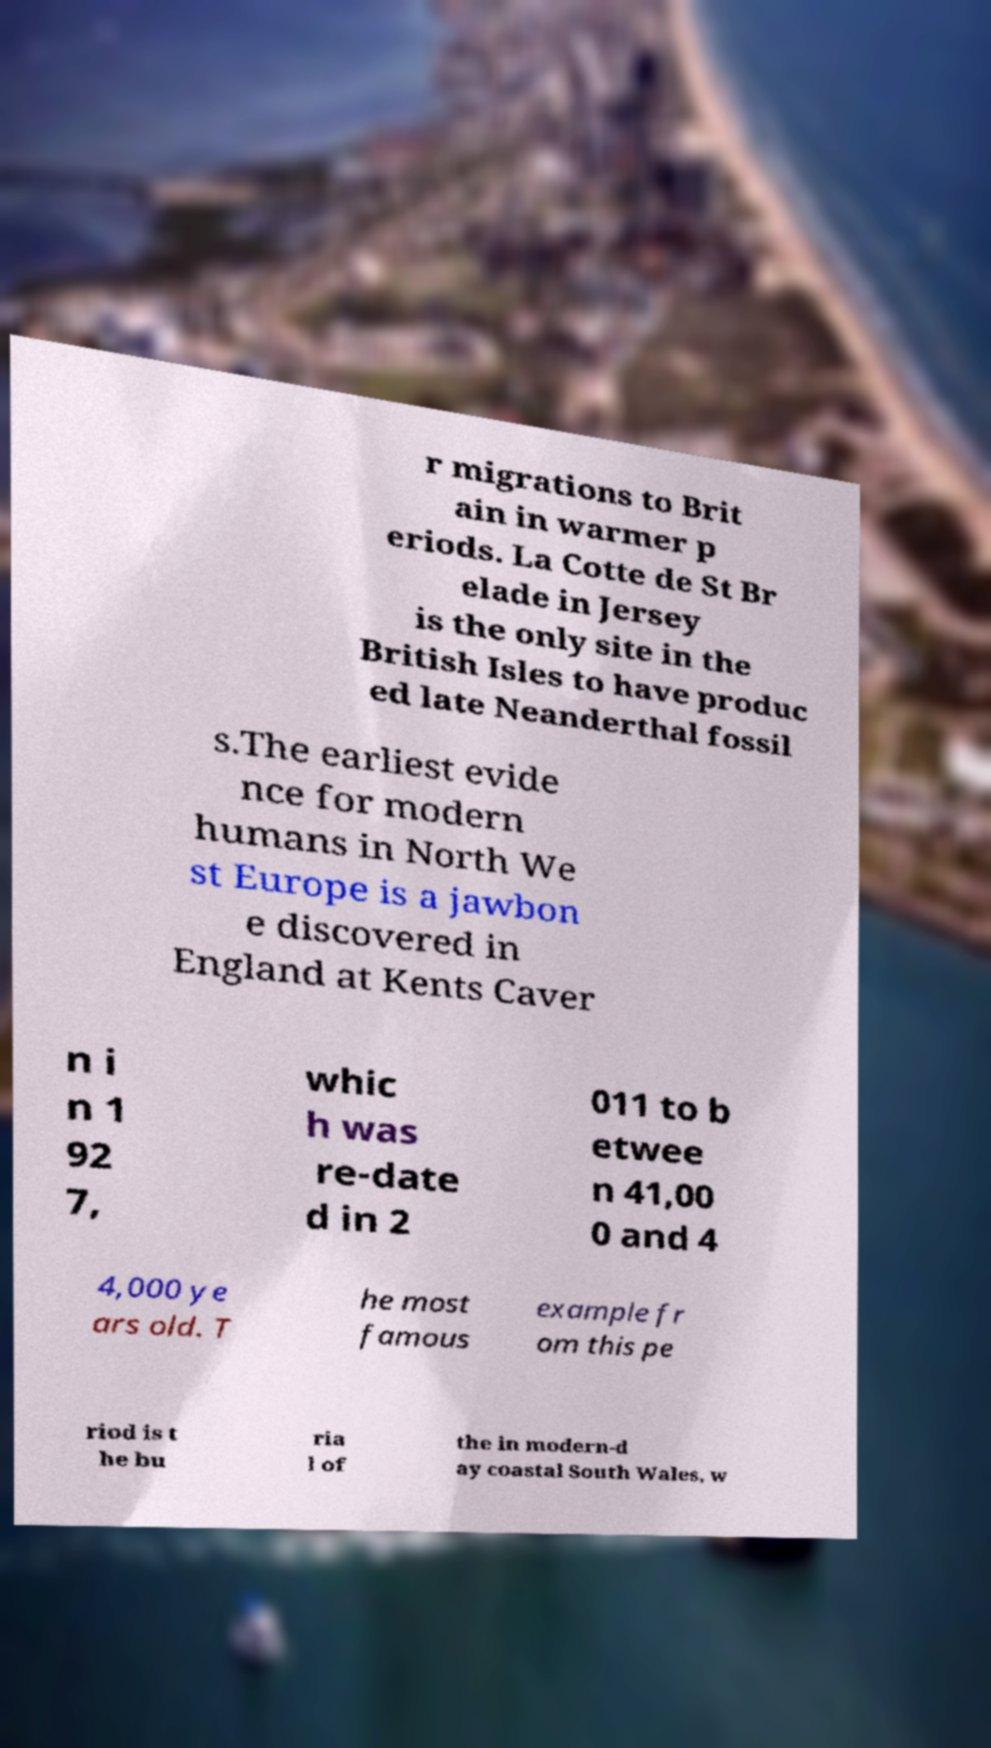There's text embedded in this image that I need extracted. Can you transcribe it verbatim? r migrations to Brit ain in warmer p eriods. La Cotte de St Br elade in Jersey is the only site in the British Isles to have produc ed late Neanderthal fossil s.The earliest evide nce for modern humans in North We st Europe is a jawbon e discovered in England at Kents Caver n i n 1 92 7, whic h was re-date d in 2 011 to b etwee n 41,00 0 and 4 4,000 ye ars old. T he most famous example fr om this pe riod is t he bu ria l of the in modern-d ay coastal South Wales, w 